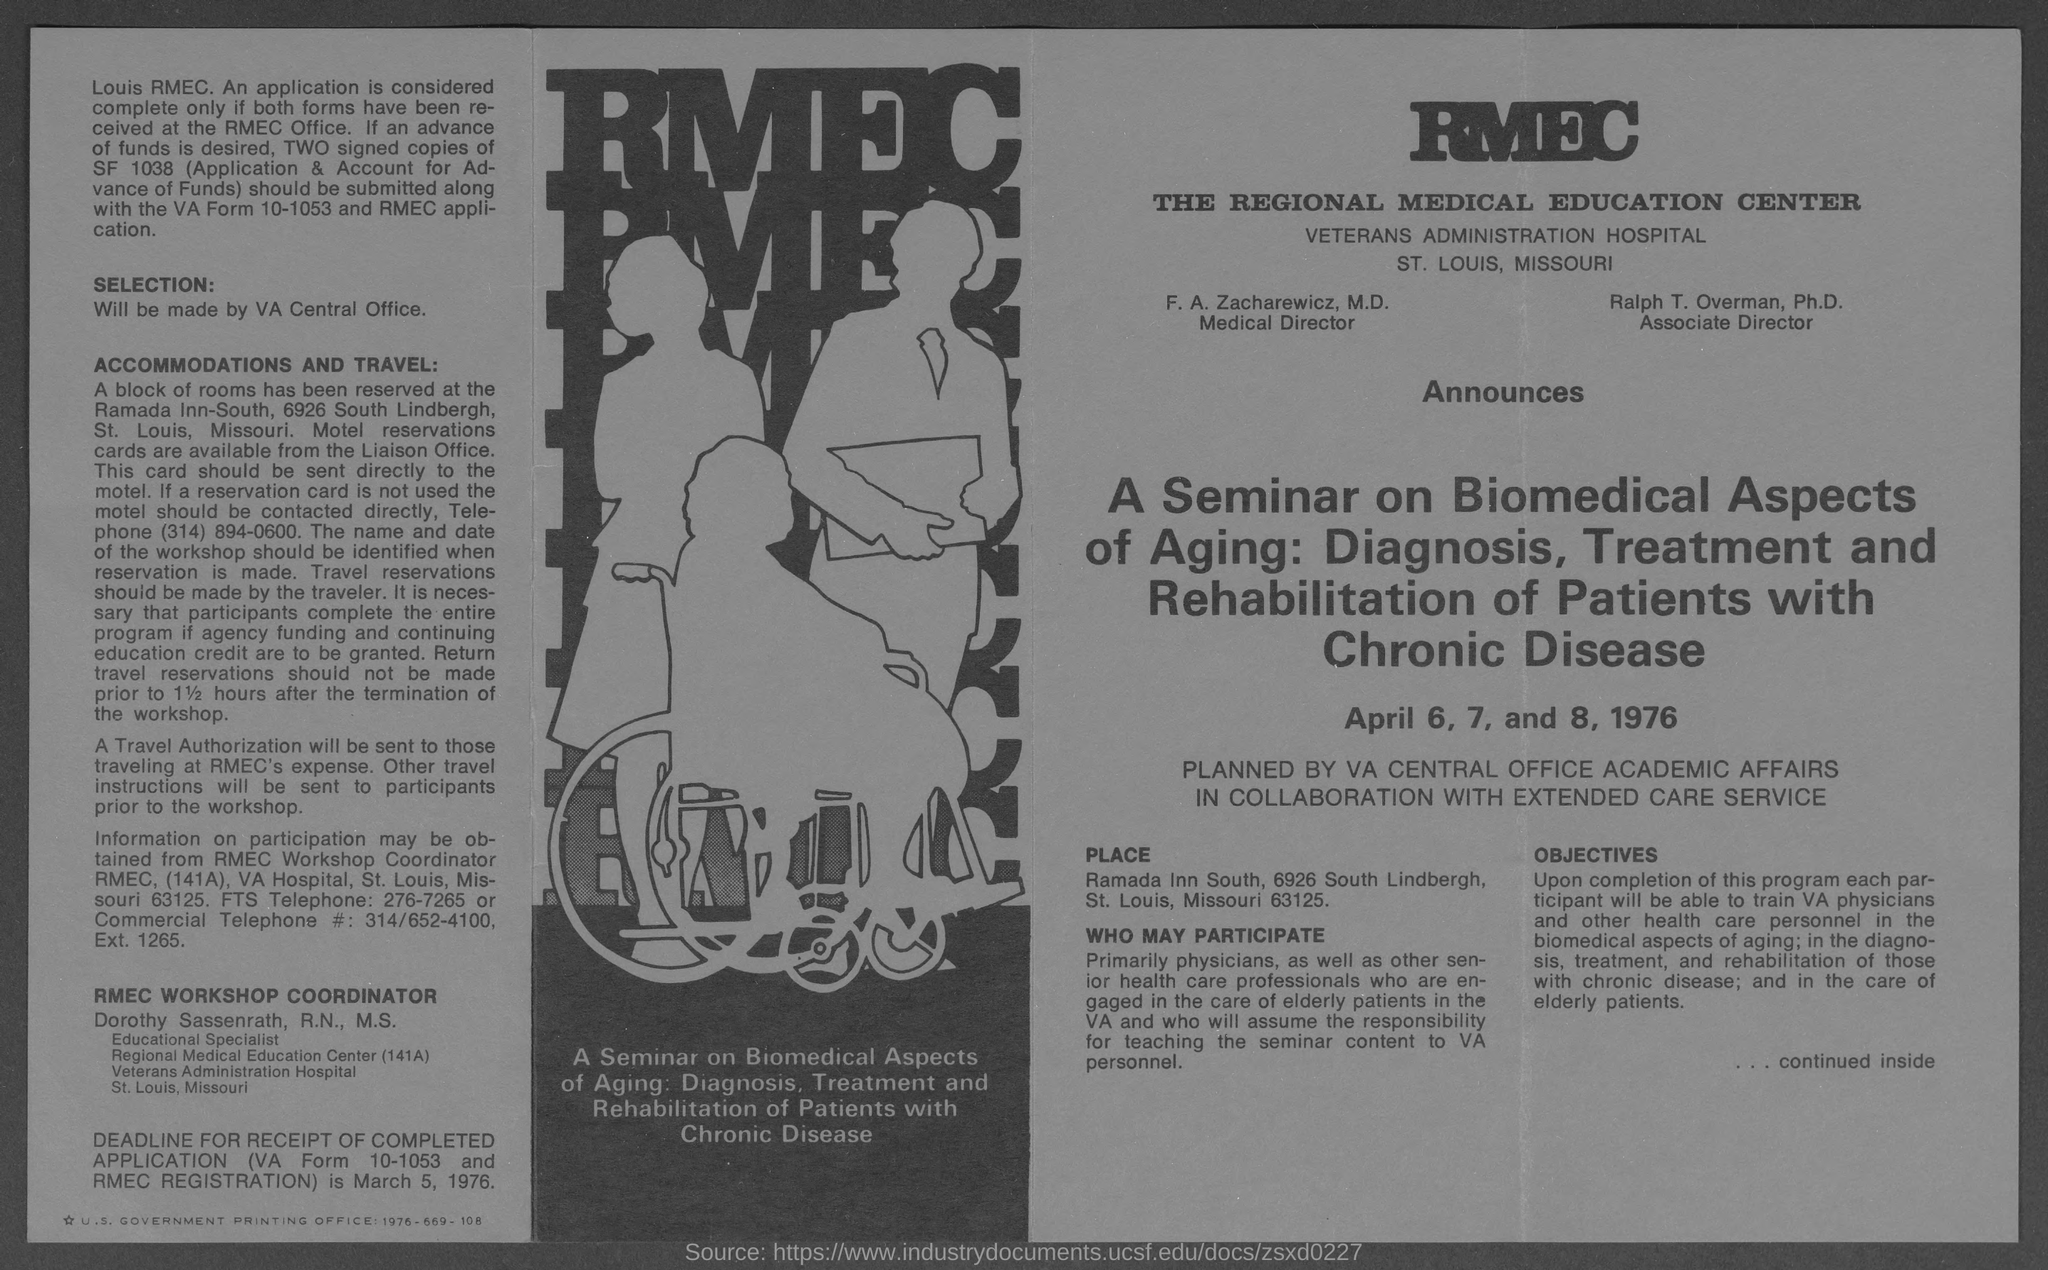What is the position of  f. a. zacharewicz ?
Offer a very short reply. Medical director. What is the position of ralph t. overman ?
Keep it short and to the point. Associate director. What is the position of dorothy sassenrath ?
Your answer should be very brief. Educational specialist. 